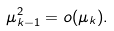Convert formula to latex. <formula><loc_0><loc_0><loc_500><loc_500>\mu _ { k - 1 } ^ { 2 } = o ( \mu _ { k } ) .</formula> 